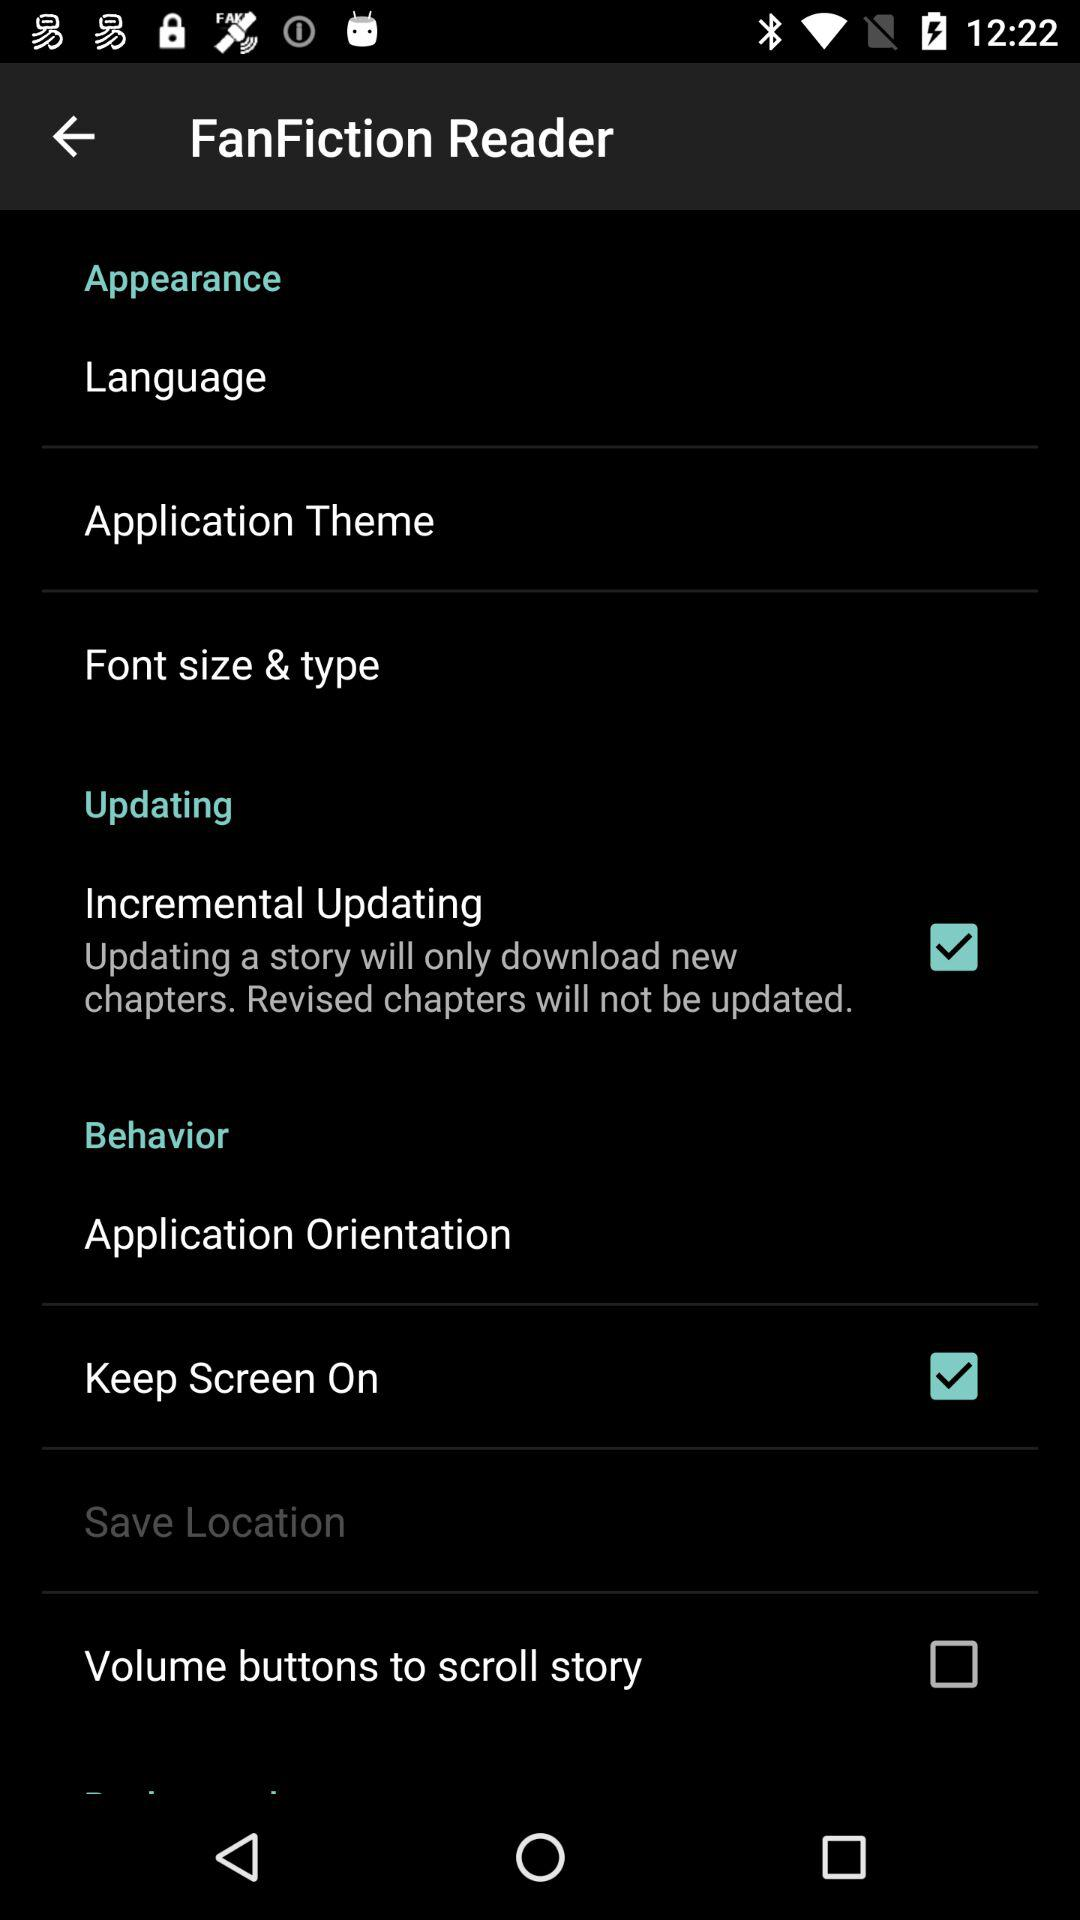Which options are selected? The options which are selected are "Incremental Updating" and "Keep Screen On". 